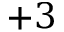<formula> <loc_0><loc_0><loc_500><loc_500>{ + 3 }</formula> 